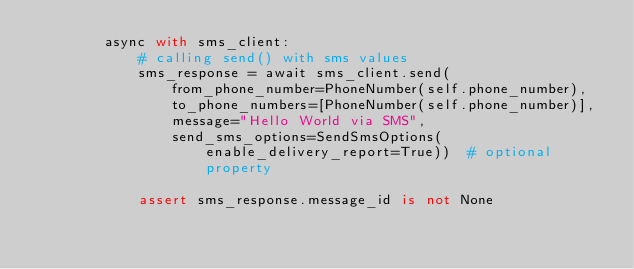<code> <loc_0><loc_0><loc_500><loc_500><_Python_>        async with sms_client:
            # calling send() with sms values
            sms_response = await sms_client.send(
                from_phone_number=PhoneNumber(self.phone_number),
                to_phone_numbers=[PhoneNumber(self.phone_number)],
                message="Hello World via SMS",
                send_sms_options=SendSmsOptions(enable_delivery_report=True))  # optional property

            assert sms_response.message_id is not None
</code> 